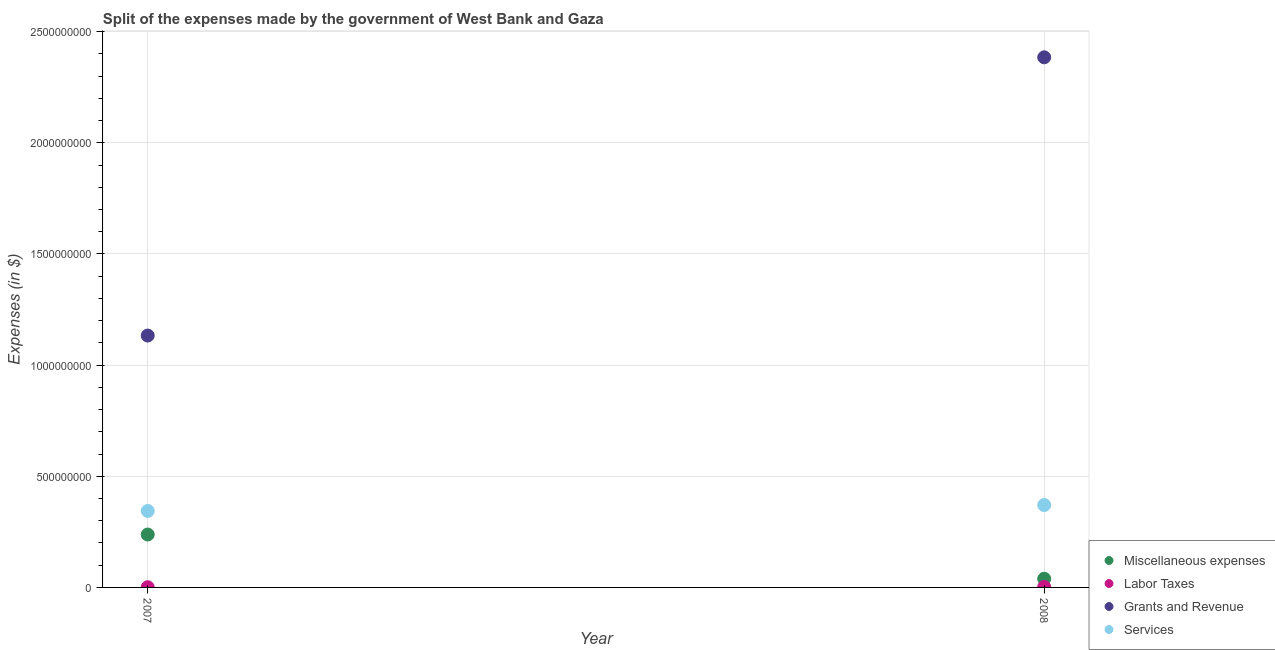What is the amount spent on grants and revenue in 2008?
Offer a very short reply. 2.38e+09. Across all years, what is the maximum amount spent on miscellaneous expenses?
Offer a very short reply. 2.38e+08. Across all years, what is the minimum amount spent on grants and revenue?
Keep it short and to the point. 1.13e+09. In which year was the amount spent on grants and revenue minimum?
Make the answer very short. 2007. What is the total amount spent on labor taxes in the graph?
Make the answer very short. 3.21e+06. What is the difference between the amount spent on miscellaneous expenses in 2007 and that in 2008?
Your response must be concise. 1.99e+08. What is the difference between the amount spent on labor taxes in 2007 and the amount spent on services in 2008?
Keep it short and to the point. -3.70e+08. What is the average amount spent on services per year?
Make the answer very short. 3.57e+08. In the year 2008, what is the difference between the amount spent on miscellaneous expenses and amount spent on services?
Offer a very short reply. -3.32e+08. What is the ratio of the amount spent on labor taxes in 2007 to that in 2008?
Your answer should be very brief. 0.45. Is the amount spent on grants and revenue in 2007 less than that in 2008?
Offer a terse response. Yes. Is it the case that in every year, the sum of the amount spent on miscellaneous expenses and amount spent on labor taxes is greater than the amount spent on grants and revenue?
Your response must be concise. No. Is the amount spent on labor taxes strictly greater than the amount spent on services over the years?
Give a very brief answer. No. How many dotlines are there?
Provide a short and direct response. 4. What is the difference between two consecutive major ticks on the Y-axis?
Offer a very short reply. 5.00e+08. Are the values on the major ticks of Y-axis written in scientific E-notation?
Keep it short and to the point. No. Does the graph contain any zero values?
Offer a very short reply. No. Does the graph contain grids?
Your answer should be very brief. Yes. How many legend labels are there?
Provide a succinct answer. 4. How are the legend labels stacked?
Offer a terse response. Vertical. What is the title of the graph?
Offer a terse response. Split of the expenses made by the government of West Bank and Gaza. Does "Tracking ability" appear as one of the legend labels in the graph?
Provide a short and direct response. No. What is the label or title of the X-axis?
Offer a very short reply. Year. What is the label or title of the Y-axis?
Offer a terse response. Expenses (in $). What is the Expenses (in $) of Miscellaneous expenses in 2007?
Your answer should be compact. 2.38e+08. What is the Expenses (in $) in Labor Taxes in 2007?
Give a very brief answer. 1.00e+06. What is the Expenses (in $) of Grants and Revenue in 2007?
Keep it short and to the point. 1.13e+09. What is the Expenses (in $) of Services in 2007?
Keep it short and to the point. 3.44e+08. What is the Expenses (in $) of Miscellaneous expenses in 2008?
Offer a terse response. 3.90e+07. What is the Expenses (in $) of Labor Taxes in 2008?
Give a very brief answer. 2.21e+06. What is the Expenses (in $) in Grants and Revenue in 2008?
Make the answer very short. 2.38e+09. What is the Expenses (in $) in Services in 2008?
Ensure brevity in your answer.  3.71e+08. Across all years, what is the maximum Expenses (in $) of Miscellaneous expenses?
Ensure brevity in your answer.  2.38e+08. Across all years, what is the maximum Expenses (in $) in Labor Taxes?
Provide a succinct answer. 2.21e+06. Across all years, what is the maximum Expenses (in $) of Grants and Revenue?
Provide a succinct answer. 2.38e+09. Across all years, what is the maximum Expenses (in $) in Services?
Provide a short and direct response. 3.71e+08. Across all years, what is the minimum Expenses (in $) of Miscellaneous expenses?
Keep it short and to the point. 3.90e+07. Across all years, what is the minimum Expenses (in $) of Grants and Revenue?
Your answer should be compact. 1.13e+09. Across all years, what is the minimum Expenses (in $) in Services?
Provide a succinct answer. 3.44e+08. What is the total Expenses (in $) of Miscellaneous expenses in the graph?
Provide a succinct answer. 2.77e+08. What is the total Expenses (in $) of Labor Taxes in the graph?
Give a very brief answer. 3.21e+06. What is the total Expenses (in $) in Grants and Revenue in the graph?
Your response must be concise. 3.52e+09. What is the total Expenses (in $) of Services in the graph?
Your answer should be compact. 7.15e+08. What is the difference between the Expenses (in $) of Miscellaneous expenses in 2007 and that in 2008?
Your answer should be very brief. 1.99e+08. What is the difference between the Expenses (in $) in Labor Taxes in 2007 and that in 2008?
Your answer should be very brief. -1.21e+06. What is the difference between the Expenses (in $) in Grants and Revenue in 2007 and that in 2008?
Offer a very short reply. -1.25e+09. What is the difference between the Expenses (in $) of Services in 2007 and that in 2008?
Your answer should be very brief. -2.67e+07. What is the difference between the Expenses (in $) in Miscellaneous expenses in 2007 and the Expenses (in $) in Labor Taxes in 2008?
Your answer should be very brief. 2.36e+08. What is the difference between the Expenses (in $) in Miscellaneous expenses in 2007 and the Expenses (in $) in Grants and Revenue in 2008?
Your answer should be compact. -2.15e+09. What is the difference between the Expenses (in $) of Miscellaneous expenses in 2007 and the Expenses (in $) of Services in 2008?
Offer a terse response. -1.33e+08. What is the difference between the Expenses (in $) in Labor Taxes in 2007 and the Expenses (in $) in Grants and Revenue in 2008?
Provide a succinct answer. -2.38e+09. What is the difference between the Expenses (in $) of Labor Taxes in 2007 and the Expenses (in $) of Services in 2008?
Provide a succinct answer. -3.70e+08. What is the difference between the Expenses (in $) in Grants and Revenue in 2007 and the Expenses (in $) in Services in 2008?
Keep it short and to the point. 7.62e+08. What is the average Expenses (in $) in Miscellaneous expenses per year?
Ensure brevity in your answer.  1.39e+08. What is the average Expenses (in $) in Labor Taxes per year?
Keep it short and to the point. 1.61e+06. What is the average Expenses (in $) of Grants and Revenue per year?
Ensure brevity in your answer.  1.76e+09. What is the average Expenses (in $) in Services per year?
Offer a terse response. 3.57e+08. In the year 2007, what is the difference between the Expenses (in $) in Miscellaneous expenses and Expenses (in $) in Labor Taxes?
Keep it short and to the point. 2.37e+08. In the year 2007, what is the difference between the Expenses (in $) of Miscellaneous expenses and Expenses (in $) of Grants and Revenue?
Your response must be concise. -8.95e+08. In the year 2007, what is the difference between the Expenses (in $) in Miscellaneous expenses and Expenses (in $) in Services?
Keep it short and to the point. -1.06e+08. In the year 2007, what is the difference between the Expenses (in $) in Labor Taxes and Expenses (in $) in Grants and Revenue?
Your answer should be very brief. -1.13e+09. In the year 2007, what is the difference between the Expenses (in $) in Labor Taxes and Expenses (in $) in Services?
Make the answer very short. -3.43e+08. In the year 2007, what is the difference between the Expenses (in $) of Grants and Revenue and Expenses (in $) of Services?
Provide a succinct answer. 7.89e+08. In the year 2008, what is the difference between the Expenses (in $) of Miscellaneous expenses and Expenses (in $) of Labor Taxes?
Ensure brevity in your answer.  3.68e+07. In the year 2008, what is the difference between the Expenses (in $) of Miscellaneous expenses and Expenses (in $) of Grants and Revenue?
Give a very brief answer. -2.35e+09. In the year 2008, what is the difference between the Expenses (in $) in Miscellaneous expenses and Expenses (in $) in Services?
Give a very brief answer. -3.32e+08. In the year 2008, what is the difference between the Expenses (in $) in Labor Taxes and Expenses (in $) in Grants and Revenue?
Your answer should be compact. -2.38e+09. In the year 2008, what is the difference between the Expenses (in $) of Labor Taxes and Expenses (in $) of Services?
Your response must be concise. -3.69e+08. In the year 2008, what is the difference between the Expenses (in $) of Grants and Revenue and Expenses (in $) of Services?
Your response must be concise. 2.01e+09. What is the ratio of the Expenses (in $) in Miscellaneous expenses in 2007 to that in 2008?
Your answer should be compact. 6.1. What is the ratio of the Expenses (in $) in Labor Taxes in 2007 to that in 2008?
Provide a short and direct response. 0.45. What is the ratio of the Expenses (in $) of Grants and Revenue in 2007 to that in 2008?
Provide a short and direct response. 0.48. What is the ratio of the Expenses (in $) of Services in 2007 to that in 2008?
Offer a very short reply. 0.93. What is the difference between the highest and the second highest Expenses (in $) in Miscellaneous expenses?
Make the answer very short. 1.99e+08. What is the difference between the highest and the second highest Expenses (in $) of Labor Taxes?
Keep it short and to the point. 1.21e+06. What is the difference between the highest and the second highest Expenses (in $) of Grants and Revenue?
Make the answer very short. 1.25e+09. What is the difference between the highest and the second highest Expenses (in $) of Services?
Offer a terse response. 2.67e+07. What is the difference between the highest and the lowest Expenses (in $) of Miscellaneous expenses?
Offer a very short reply. 1.99e+08. What is the difference between the highest and the lowest Expenses (in $) of Labor Taxes?
Offer a terse response. 1.21e+06. What is the difference between the highest and the lowest Expenses (in $) of Grants and Revenue?
Provide a succinct answer. 1.25e+09. What is the difference between the highest and the lowest Expenses (in $) of Services?
Offer a terse response. 2.67e+07. 